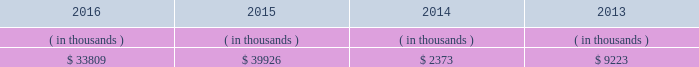System energy resources , inc .
Management 2019s financial discussion and analysis also in addition to the contractual obligations , system energy has $ 382.3 million of unrecognized tax benefits and interest net of unused tax attributes and payments for which the timing of payments beyond 12 months cannot be reasonably estimated due to uncertainties in the timing of effective settlement of tax positions .
See note 3 to the financial statements for additional information regarding unrecognized tax benefits .
In addition to routine spending to maintain operations , the planned capital investment estimate includes specific investments and initiatives such as the nuclear fleet operational excellence initiative , as discussed below in 201cnuclear matters , 201d and plant improvements .
As a wholly-owned subsidiary , system energy dividends its earnings to entergy corporation at a percentage determined monthly .
Sources of capital system energy 2019s sources to meet its capital requirements include : 2022 internally generated funds ; 2022 cash on hand ; 2022 debt issuances ; and 2022 bank financing under new or existing facilities .
System energy may refinance , redeem , or otherwise retire debt prior to maturity , to the extent market conditions and interest and dividend rates are favorable .
All debt and common stock issuances by system energy require prior regulatory approval .
Debt issuances are also subject to issuance tests set forth in its bond indentures and other agreements .
System energy has sufficient capacity under these tests to meet its foreseeable capital needs .
System energy 2019s receivables from the money pool were as follows as of december 31 for each of the following years. .
See note 4 to the financial statements for a description of the money pool .
The system energy nuclear fuel company variable interest entity has a credit facility in the amount of $ 120 million scheduled to expire in may 2019 .
As of december 31 , 2016 , $ 66.9 million in letters of credit were outstanding under the credit facility to support a like amount of commercial paper issued by the system energy nuclear fuel company variable interest entity .
See note 4 to the financial statements for additional discussion of the variable interest entity credit facility .
System energy obtained authorizations from the ferc through october 2017 for the following : 2022 short-term borrowings not to exceed an aggregate amount of $ 200 million at any time outstanding ; 2022 long-term borrowings and security issuances ; and 2022 long-term borrowings by its nuclear fuel company variable interest entity .
See note 4 to the financial statements for further discussion of system energy 2019s short-term borrowing limits. .
As of december 31 , 2016 , what is the remaining capacity ( in millions ) for the credit facility scheduled to expire in may 2019? 
Computations: (120 - 66.9)
Answer: 53.1. 